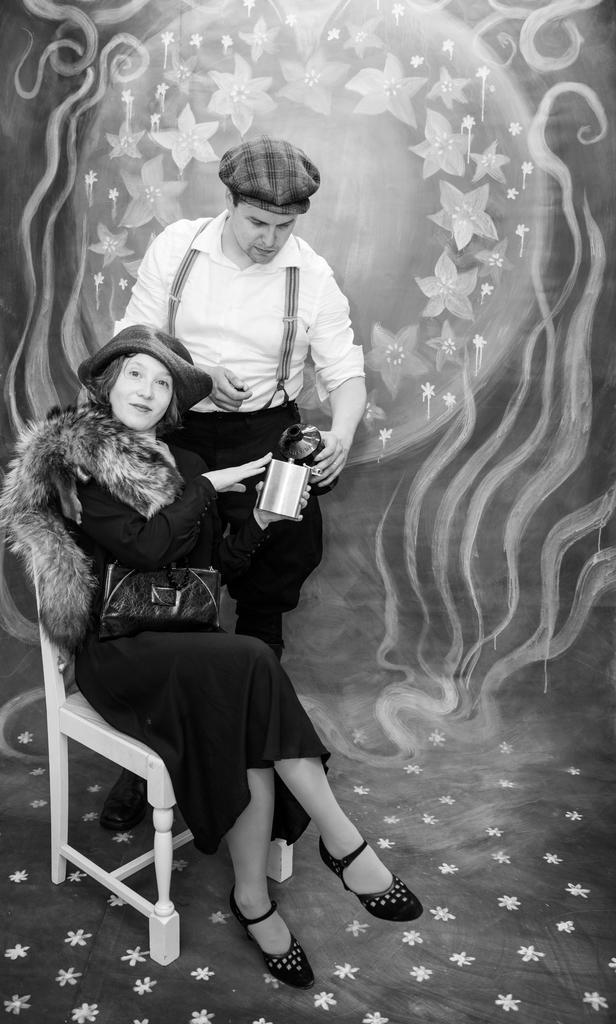Can you describe this image briefly? It is a black and white image there is a woman sitting on a chair and posing for the photo and behind her there is a man, in the background there is some art work. 